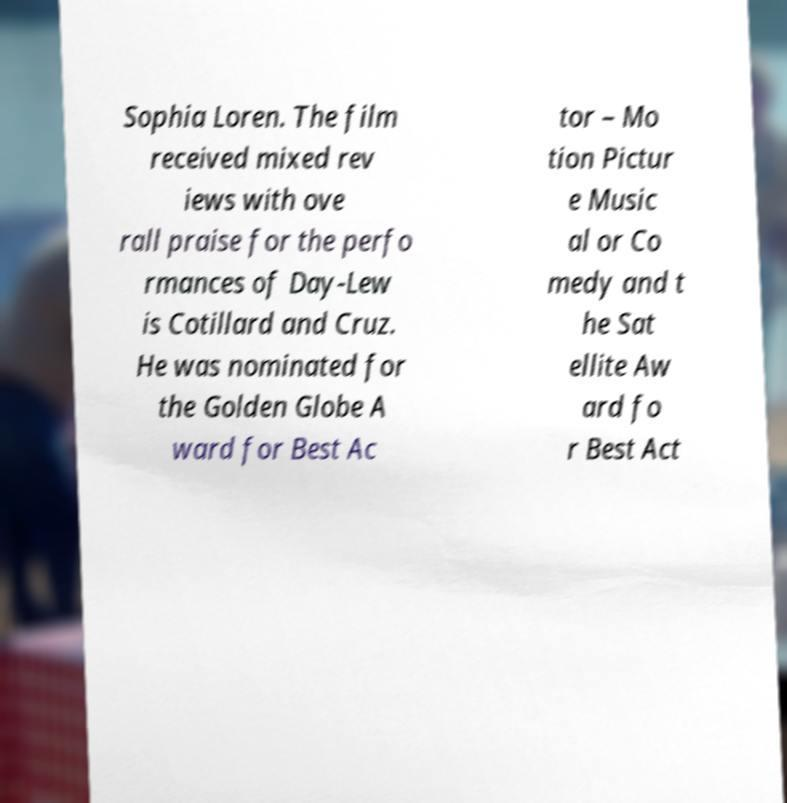Can you accurately transcribe the text from the provided image for me? Sophia Loren. The film received mixed rev iews with ove rall praise for the perfo rmances of Day-Lew is Cotillard and Cruz. He was nominated for the Golden Globe A ward for Best Ac tor – Mo tion Pictur e Music al or Co medy and t he Sat ellite Aw ard fo r Best Act 